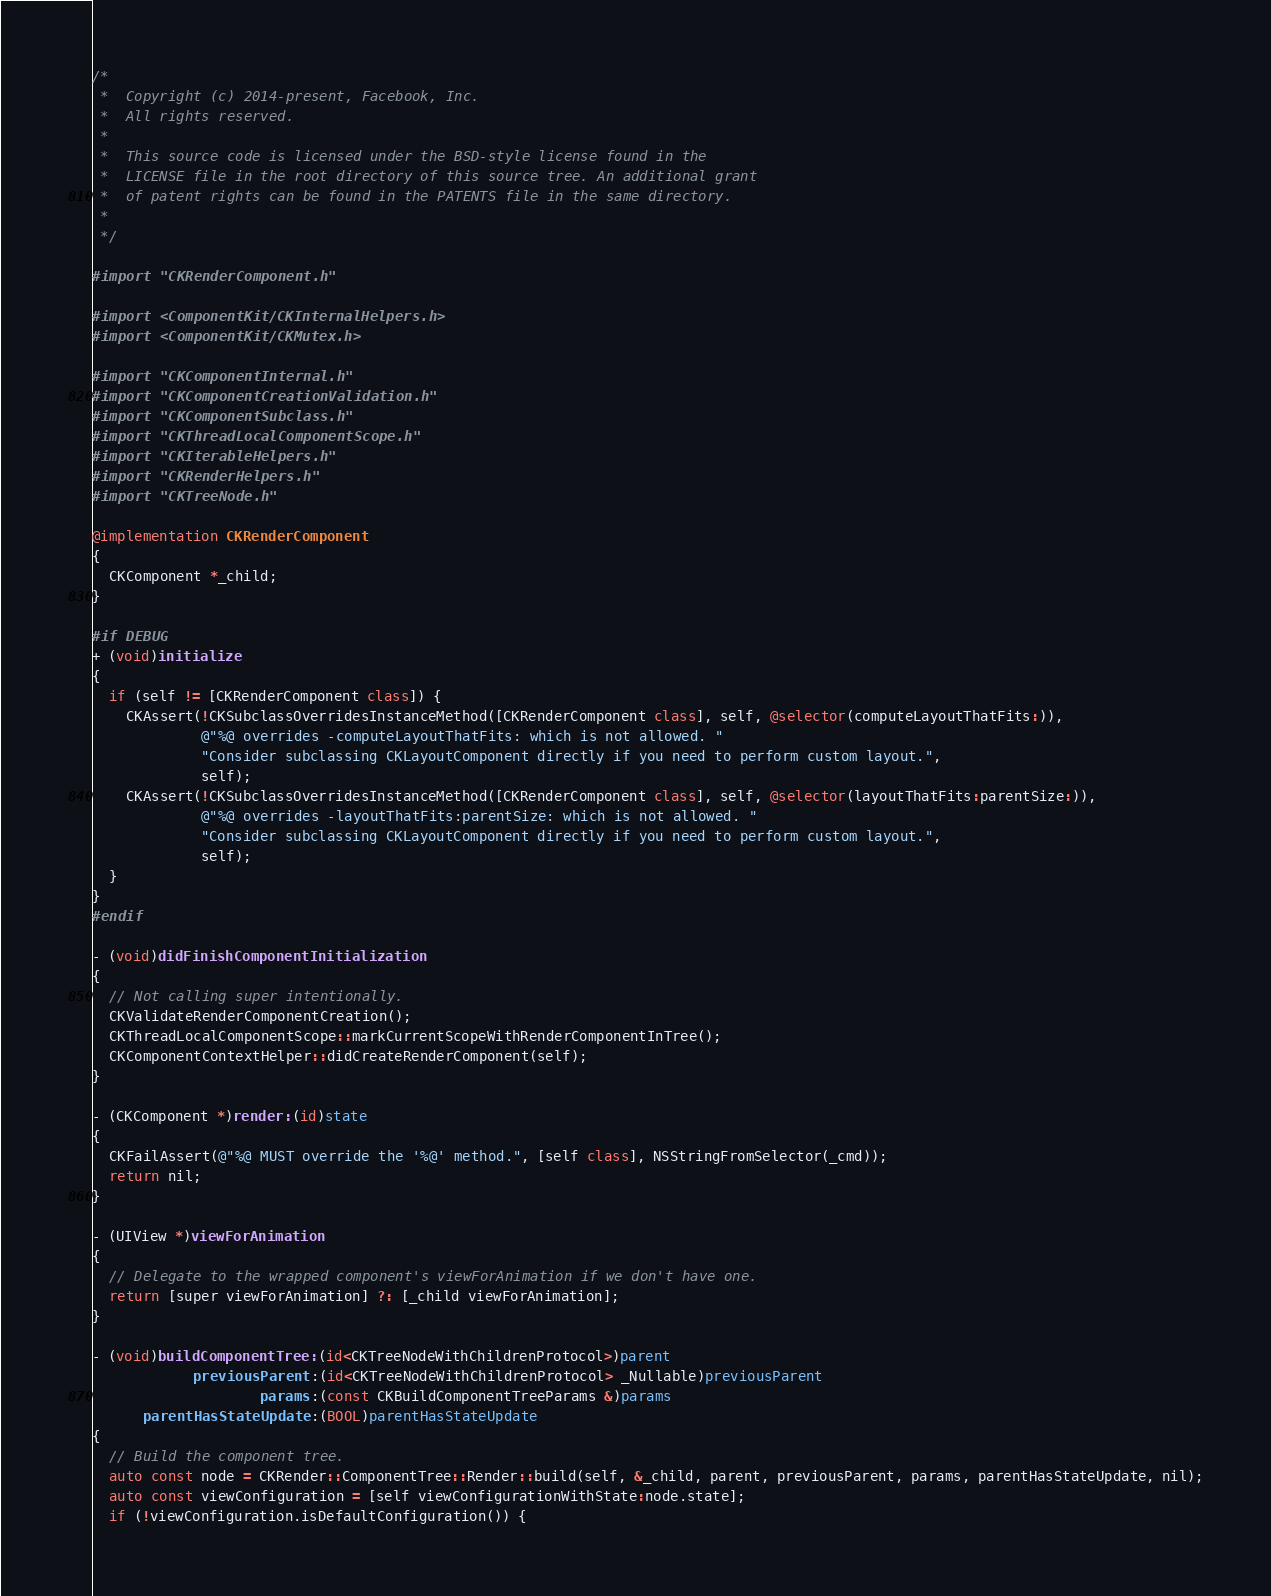<code> <loc_0><loc_0><loc_500><loc_500><_ObjectiveC_>/*
 *  Copyright (c) 2014-present, Facebook, Inc.
 *  All rights reserved.
 *
 *  This source code is licensed under the BSD-style license found in the
 *  LICENSE file in the root directory of this source tree. An additional grant
 *  of patent rights can be found in the PATENTS file in the same directory.
 *
 */

#import "CKRenderComponent.h"

#import <ComponentKit/CKInternalHelpers.h>
#import <ComponentKit/CKMutex.h>

#import "CKComponentInternal.h"
#import "CKComponentCreationValidation.h"
#import "CKComponentSubclass.h"
#import "CKThreadLocalComponentScope.h"
#import "CKIterableHelpers.h"
#import "CKRenderHelpers.h"
#import "CKTreeNode.h"

@implementation CKRenderComponent
{
  CKComponent *_child;
}

#if DEBUG
+ (void)initialize
{
  if (self != [CKRenderComponent class]) {
    CKAssert(!CKSubclassOverridesInstanceMethod([CKRenderComponent class], self, @selector(computeLayoutThatFits:)),
             @"%@ overrides -computeLayoutThatFits: which is not allowed. "
             "Consider subclassing CKLayoutComponent directly if you need to perform custom layout.",
             self);
    CKAssert(!CKSubclassOverridesInstanceMethod([CKRenderComponent class], self, @selector(layoutThatFits:parentSize:)),
             @"%@ overrides -layoutThatFits:parentSize: which is not allowed. "
             "Consider subclassing CKLayoutComponent directly if you need to perform custom layout.",
             self);
  }
}
#endif

- (void)didFinishComponentInitialization
{
  // Not calling super intentionally.
  CKValidateRenderComponentCreation();
  CKThreadLocalComponentScope::markCurrentScopeWithRenderComponentInTree();
  CKComponentContextHelper::didCreateRenderComponent(self);
}

- (CKComponent *)render:(id)state
{
  CKFailAssert(@"%@ MUST override the '%@' method.", [self class], NSStringFromSelector(_cmd));
  return nil;
}

- (UIView *)viewForAnimation
{
  // Delegate to the wrapped component's viewForAnimation if we don't have one.
  return [super viewForAnimation] ?: [_child viewForAnimation];
}

- (void)buildComponentTree:(id<CKTreeNodeWithChildrenProtocol>)parent
            previousParent:(id<CKTreeNodeWithChildrenProtocol> _Nullable)previousParent
                    params:(const CKBuildComponentTreeParams &)params
      parentHasStateUpdate:(BOOL)parentHasStateUpdate
{
  // Build the component tree.
  auto const node = CKRender::ComponentTree::Render::build(self, &_child, parent, previousParent, params, parentHasStateUpdate, nil);
  auto const viewConfiguration = [self viewConfigurationWithState:node.state];
  if (!viewConfiguration.isDefaultConfiguration()) {</code> 